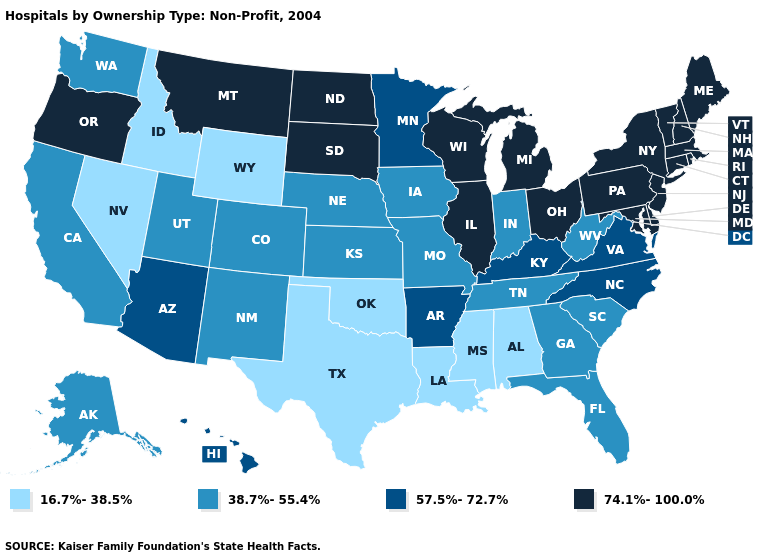Does Ohio have a higher value than Hawaii?
Keep it brief. Yes. Name the states that have a value in the range 74.1%-100.0%?
Quick response, please. Connecticut, Delaware, Illinois, Maine, Maryland, Massachusetts, Michigan, Montana, New Hampshire, New Jersey, New York, North Dakota, Ohio, Oregon, Pennsylvania, Rhode Island, South Dakota, Vermont, Wisconsin. Does the map have missing data?
Short answer required. No. Does the map have missing data?
Answer briefly. No. What is the highest value in the USA?
Short answer required. 74.1%-100.0%. What is the value of Tennessee?
Give a very brief answer. 38.7%-55.4%. What is the value of Oklahoma?
Quick response, please. 16.7%-38.5%. Which states have the highest value in the USA?
Concise answer only. Connecticut, Delaware, Illinois, Maine, Maryland, Massachusetts, Michigan, Montana, New Hampshire, New Jersey, New York, North Dakota, Ohio, Oregon, Pennsylvania, Rhode Island, South Dakota, Vermont, Wisconsin. What is the highest value in states that border Delaware?
Be succinct. 74.1%-100.0%. What is the lowest value in states that border Connecticut?
Concise answer only. 74.1%-100.0%. What is the lowest value in states that border New Jersey?
Quick response, please. 74.1%-100.0%. Name the states that have a value in the range 16.7%-38.5%?
Answer briefly. Alabama, Idaho, Louisiana, Mississippi, Nevada, Oklahoma, Texas, Wyoming. What is the lowest value in the MidWest?
Answer briefly. 38.7%-55.4%. Which states hav the highest value in the MidWest?
Be succinct. Illinois, Michigan, North Dakota, Ohio, South Dakota, Wisconsin. What is the lowest value in the USA?
Concise answer only. 16.7%-38.5%. 